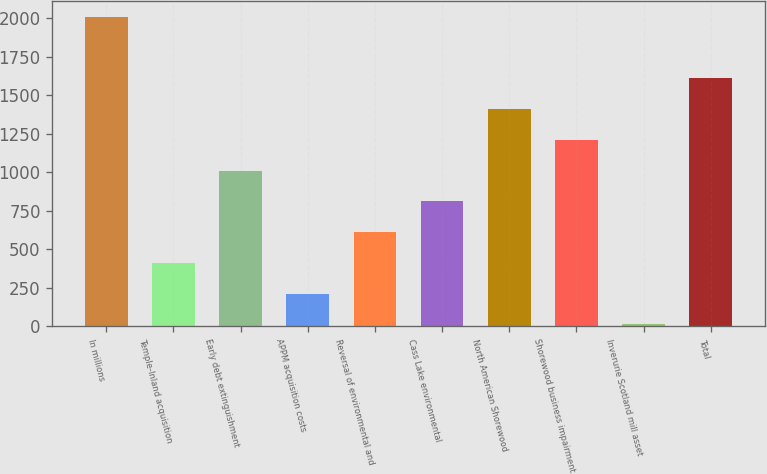<chart> <loc_0><loc_0><loc_500><loc_500><bar_chart><fcel>In millions<fcel>Temple-Inland acquisition<fcel>Early debt extinguishment<fcel>APPM acquisition costs<fcel>Reversal of environmental and<fcel>Cass Lake environmental<fcel>North American Shorewood<fcel>Shorewood business impairment<fcel>Inverurie Scotland mill asset<fcel>Total<nl><fcel>2011<fcel>411<fcel>1011<fcel>211<fcel>611<fcel>811<fcel>1411<fcel>1211<fcel>11<fcel>1611<nl></chart> 